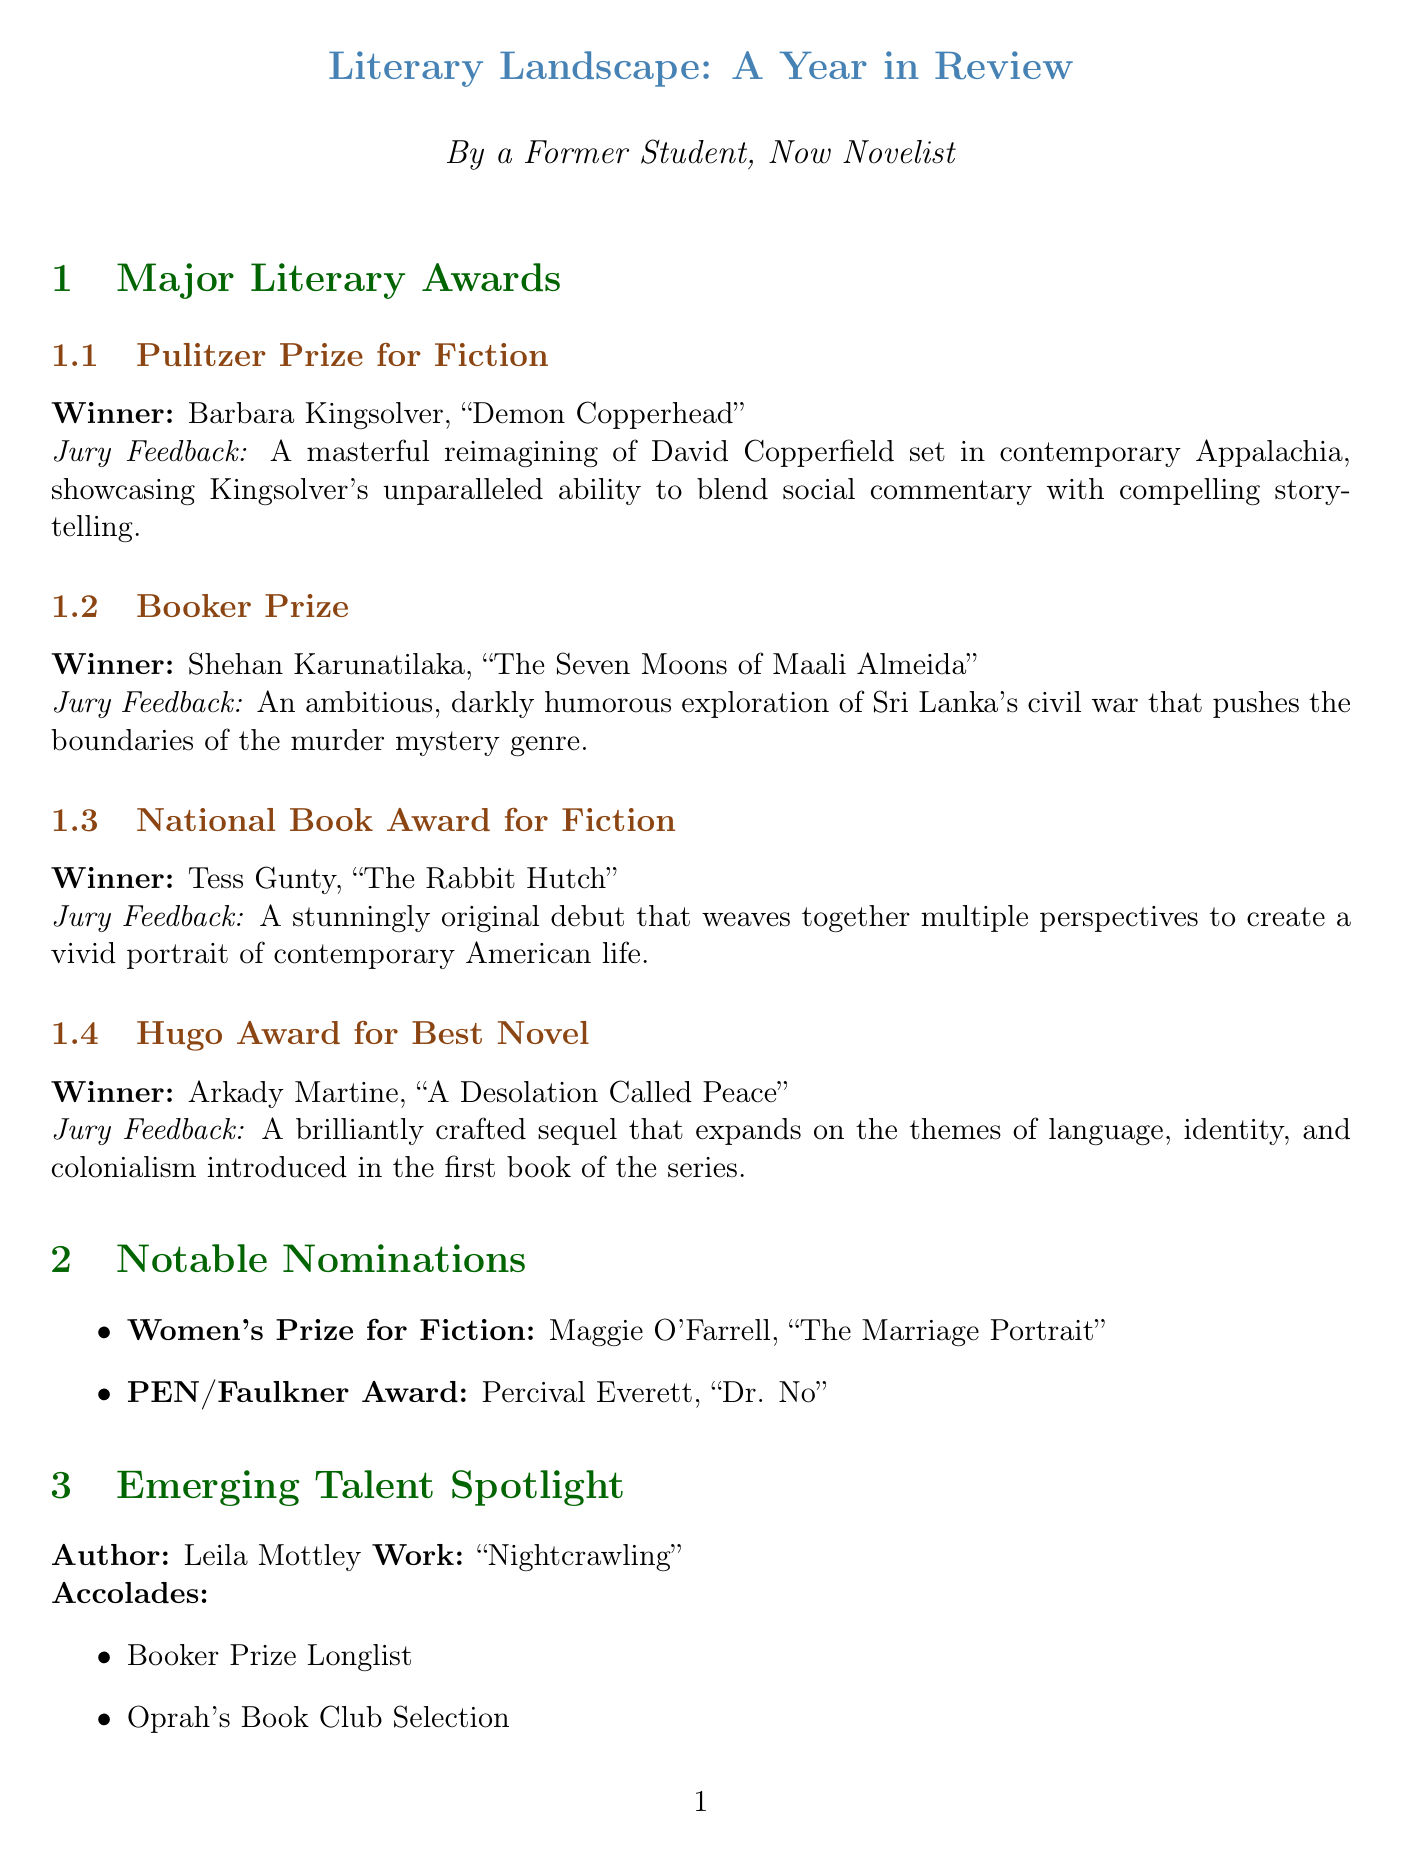What is the winner of the Pulitzer Prize for Fiction? The document lists Barbara Kingsolver as the winner of the Pulitzer Prize for Fiction for her book "Demon Copperhead."
Answer: Barbara Kingsolver What is the title of the winning work for the Booker Prize? The document states that the winning work for the Booker Prize is "The Seven Moons of Maali Almeida."
Answer: The Seven Moons of Maali Almeida Who is the author spotlighted for emerging talent? The document identifies Leila Mottley as the author in the emerging talent spotlight.
Answer: Leila Mottley What theme is explored in "The Seven Moons of Maali Almeida"? The jury feedback refers to it as an exploration of Sri Lanka's civil war and the murder mystery genre.
Answer: Sri Lanka's civil war What accolade is mentioned for "Nightcrawling"? The document states that "Nightcrawling" is a Booker Prize Longlist selection.
Answer: Booker Prize Longlist What trend emphasizes diverse voices in literature? The document points out the increased focus on diverse voices and perspectives as a significant trend.
Answer: Increased focus on diverse voices How many major literary awards are summarized in the document? The document lists four major literary awards provided in its summary.
Answer: Four Which nominated work is described as historical fiction? The document notes "The Marriage Portrait" by Maggie O'Farrell as a mesmerizing historical novel.
Answer: The Marriage Portrait 